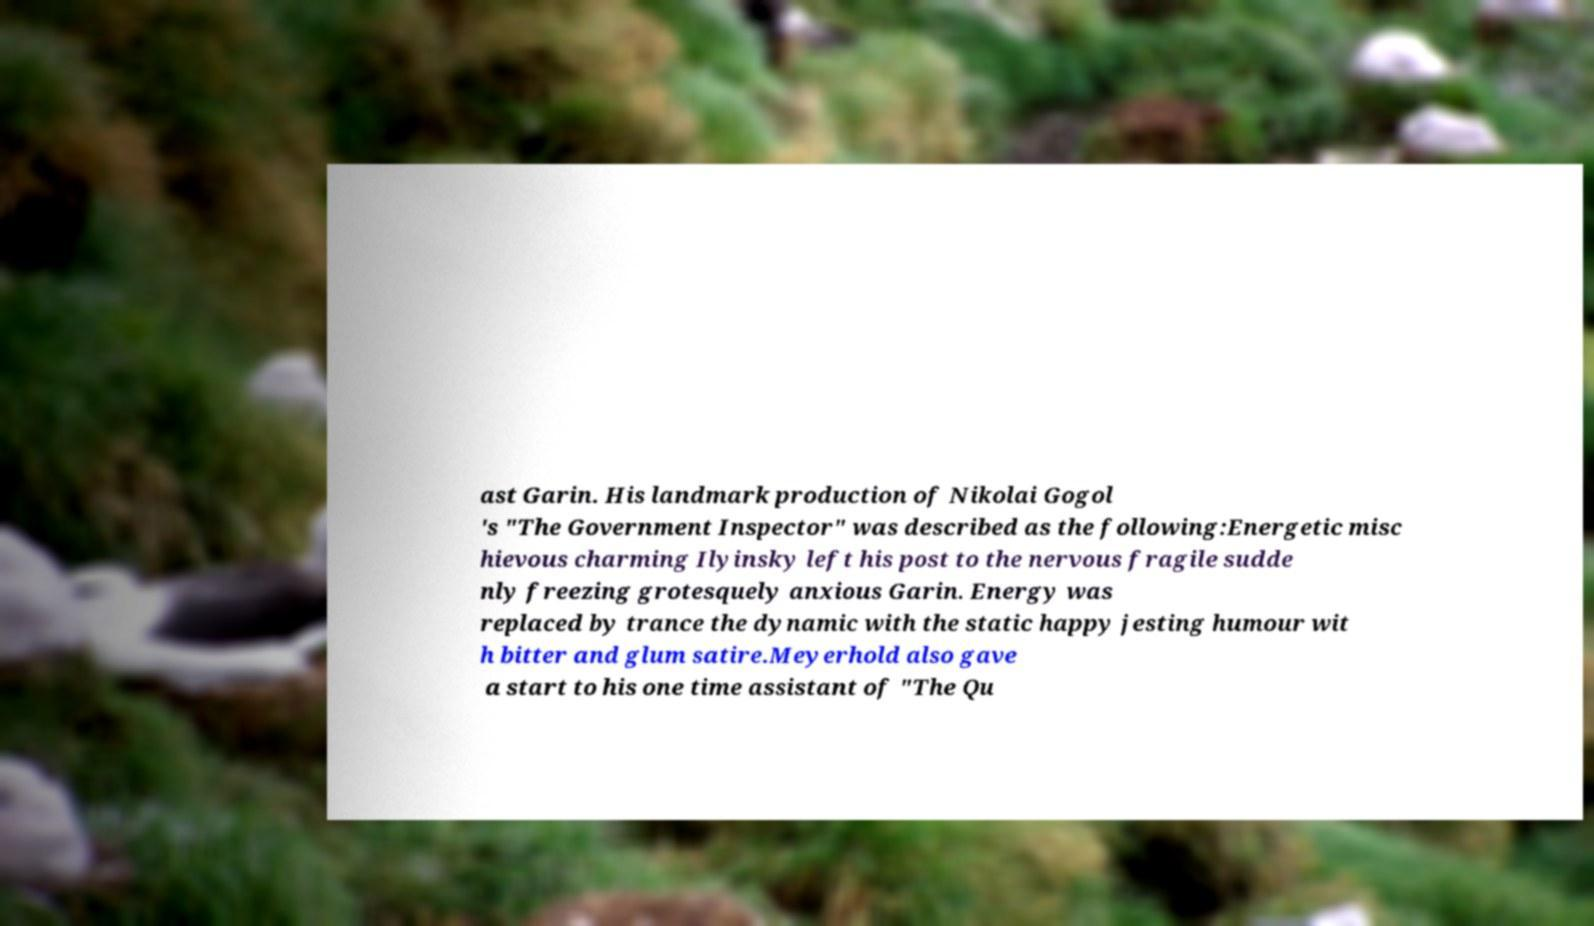For documentation purposes, I need the text within this image transcribed. Could you provide that? ast Garin. His landmark production of Nikolai Gogol 's "The Government Inspector" was described as the following:Energetic misc hievous charming Ilyinsky left his post to the nervous fragile sudde nly freezing grotesquely anxious Garin. Energy was replaced by trance the dynamic with the static happy jesting humour wit h bitter and glum satire.Meyerhold also gave a start to his one time assistant of "The Qu 